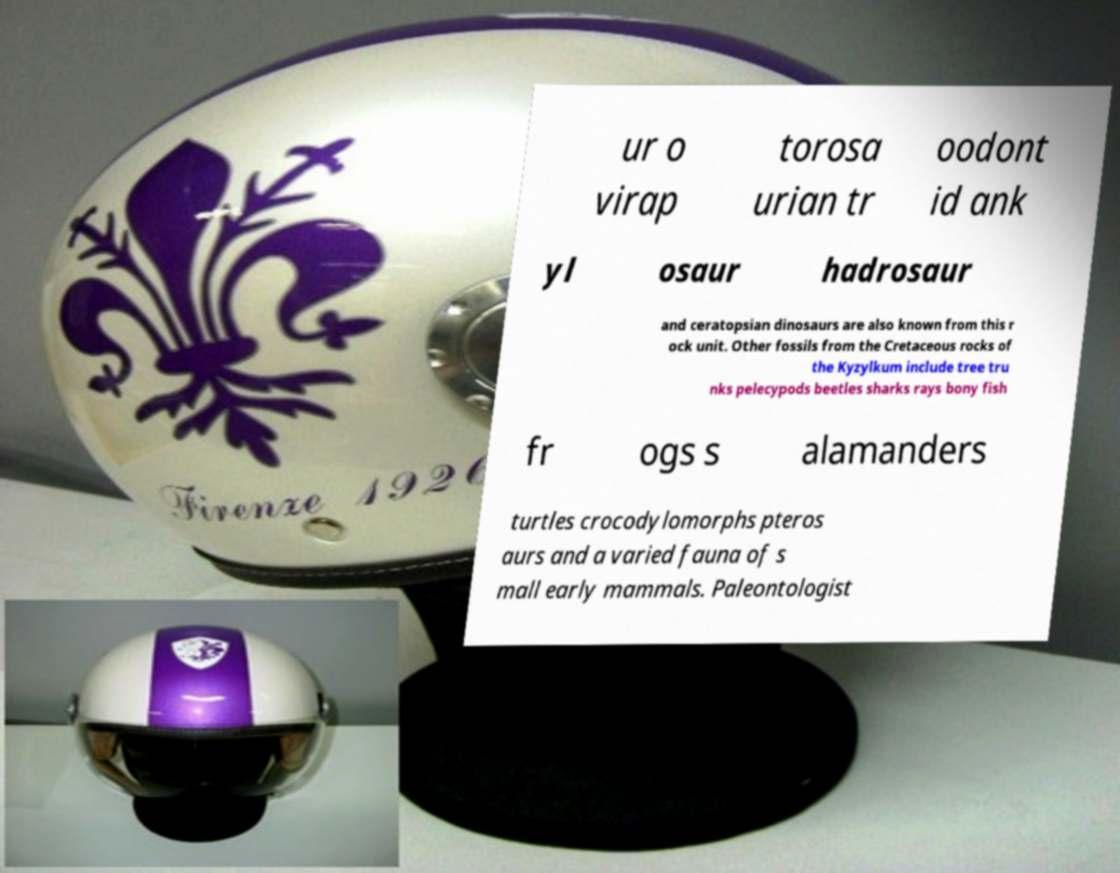Please read and relay the text visible in this image. What does it say? ur o virap torosa urian tr oodont id ank yl osaur hadrosaur and ceratopsian dinosaurs are also known from this r ock unit. Other fossils from the Cretaceous rocks of the Kyzylkum include tree tru nks pelecypods beetles sharks rays bony fish fr ogs s alamanders turtles crocodylomorphs pteros aurs and a varied fauna of s mall early mammals. Paleontologist 